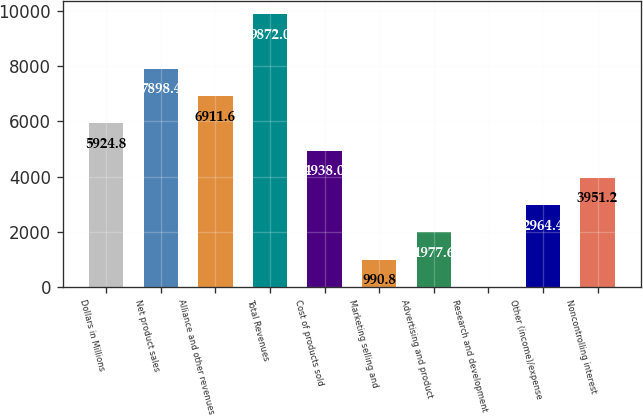<chart> <loc_0><loc_0><loc_500><loc_500><bar_chart><fcel>Dollars in Millions<fcel>Net product sales<fcel>Alliance and other revenues<fcel>Total Revenues<fcel>Cost of products sold<fcel>Marketing selling and<fcel>Advertising and product<fcel>Research and development<fcel>Other (income)/expense<fcel>Noncontrolling interest<nl><fcel>5924.8<fcel>7898.4<fcel>6911.6<fcel>9872<fcel>4938<fcel>990.8<fcel>1977.6<fcel>4<fcel>2964.4<fcel>3951.2<nl></chart> 